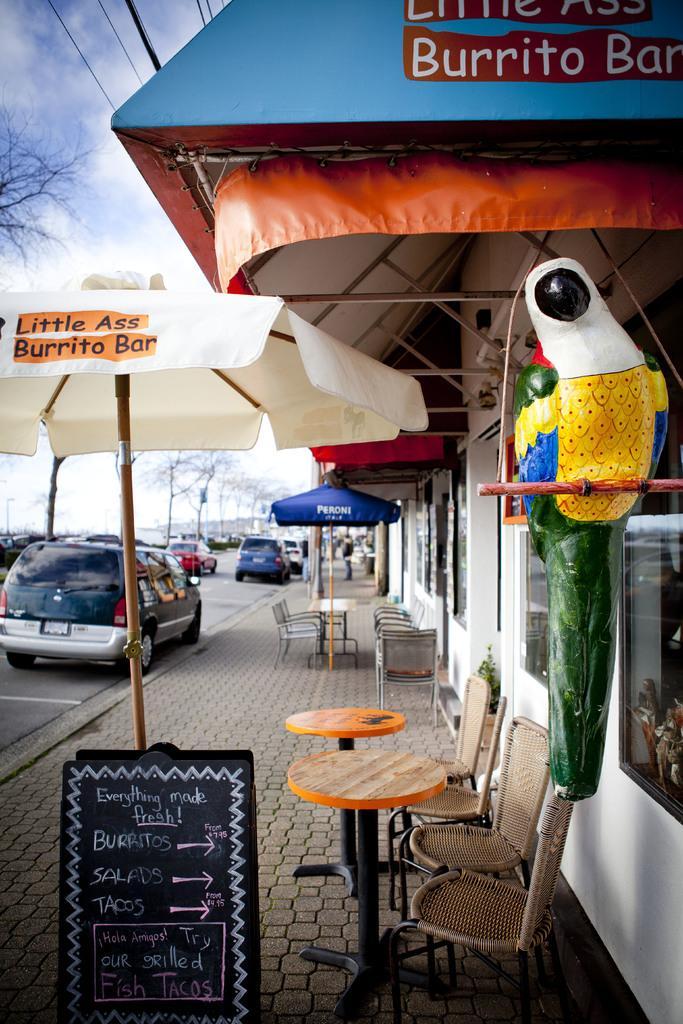Can you describe this image briefly? In this picture we can observe chairs and tables. There is a black color board under this white color umbrella. We can observe some cars on the road. On the right side we can observe a statue of a bird which is in white and yellow color. There is a building on the right side. In the background we can observe a sky with some clouds. 